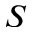<formula> <loc_0><loc_0><loc_500><loc_500>S</formula> 